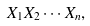Convert formula to latex. <formula><loc_0><loc_0><loc_500><loc_500>X _ { 1 } X _ { 2 } \cdots X _ { n } ,</formula> 